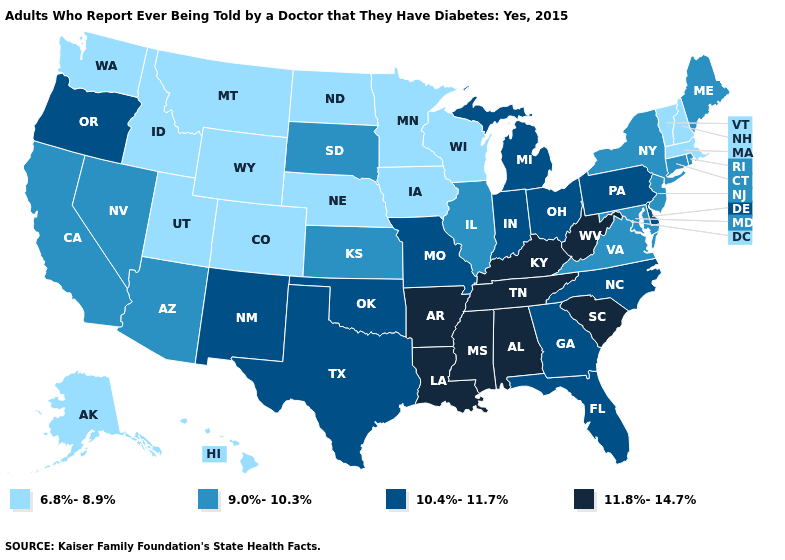What is the lowest value in the USA?
Give a very brief answer. 6.8%-8.9%. Does Utah have the highest value in the USA?
Short answer required. No. Which states hav the highest value in the West?
Be succinct. New Mexico, Oregon. What is the value of Connecticut?
Give a very brief answer. 9.0%-10.3%. Does New York have the lowest value in the USA?
Quick response, please. No. Does Rhode Island have a lower value than California?
Be succinct. No. What is the highest value in the West ?
Short answer required. 10.4%-11.7%. Does Massachusetts have the lowest value in the USA?
Concise answer only. Yes. Does the first symbol in the legend represent the smallest category?
Give a very brief answer. Yes. Name the states that have a value in the range 11.8%-14.7%?
Be succinct. Alabama, Arkansas, Kentucky, Louisiana, Mississippi, South Carolina, Tennessee, West Virginia. What is the lowest value in the West?
Write a very short answer. 6.8%-8.9%. Does California have the lowest value in the West?
Write a very short answer. No. What is the value of Alabama?
Short answer required. 11.8%-14.7%. What is the highest value in states that border New Mexico?
Write a very short answer. 10.4%-11.7%. Which states hav the highest value in the South?
Answer briefly. Alabama, Arkansas, Kentucky, Louisiana, Mississippi, South Carolina, Tennessee, West Virginia. 